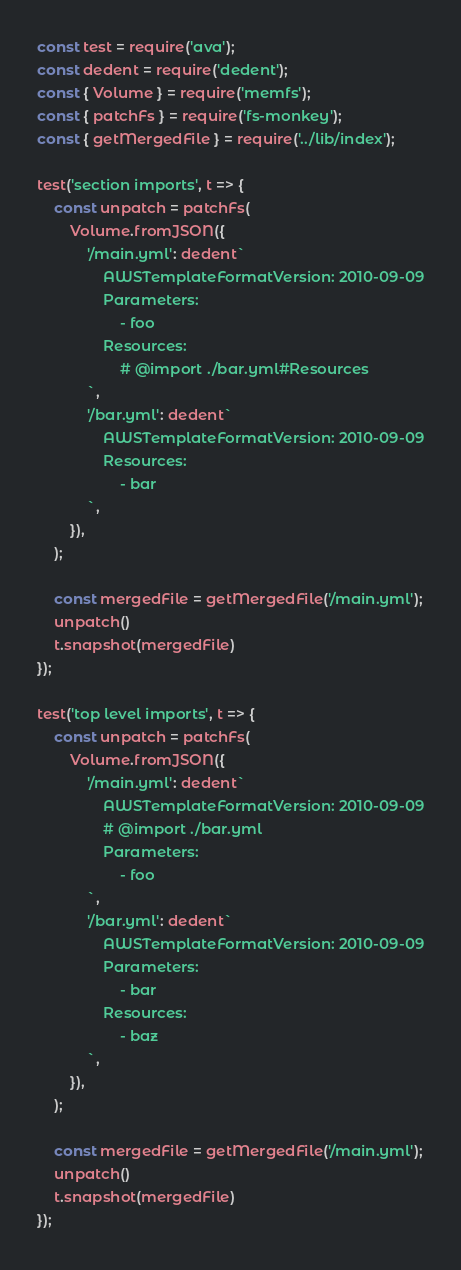<code> <loc_0><loc_0><loc_500><loc_500><_JavaScript_>const test = require('ava');
const dedent = require('dedent');
const { Volume } = require('memfs');
const { patchFs } = require('fs-monkey');
const { getMergedFile } = require('../lib/index');

test('section imports', t => {
    const unpatch = patchFs(
        Volume.fromJSON({
            '/main.yml': dedent`
                AWSTemplateFormatVersion: 2010-09-09
                Parameters:
                    - foo
                Resources:
                    # @import ./bar.yml#Resources
            `,
            '/bar.yml': dedent`
                AWSTemplateFormatVersion: 2010-09-09
                Resources:
                    - bar
            `,
        }),
    );

    const mergedFile = getMergedFile('/main.yml');
    unpatch()
    t.snapshot(mergedFile)
});

test('top level imports', t => {
    const unpatch = patchFs(
        Volume.fromJSON({
            '/main.yml': dedent`
                AWSTemplateFormatVersion: 2010-09-09
                # @import ./bar.yml
                Parameters:
                    - foo
            `,
            '/bar.yml': dedent`
                AWSTemplateFormatVersion: 2010-09-09
                Parameters:
                    - bar
                Resources:
                    - baz
            `,
        }),
    );

    const mergedFile = getMergedFile('/main.yml');
    unpatch()
    t.snapshot(mergedFile)
});
</code> 